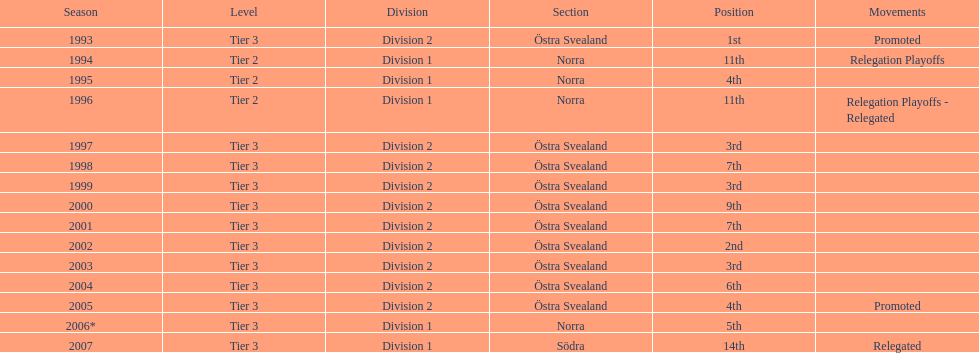Could you parse the entire table? {'header': ['Season', 'Level', 'Division', 'Section', 'Position', 'Movements'], 'rows': [['1993', 'Tier 3', 'Division 2', 'Östra Svealand', '1st', 'Promoted'], ['1994', 'Tier 2', 'Division 1', 'Norra', '11th', 'Relegation Playoffs'], ['1995', 'Tier 2', 'Division 1', 'Norra', '4th', ''], ['1996', 'Tier 2', 'Division 1', 'Norra', '11th', 'Relegation Playoffs - Relegated'], ['1997', 'Tier 3', 'Division 2', 'Östra Svealand', '3rd', ''], ['1998', 'Tier 3', 'Division 2', 'Östra Svealand', '7th', ''], ['1999', 'Tier 3', 'Division 2', 'Östra Svealand', '3rd', ''], ['2000', 'Tier 3', 'Division 2', 'Östra Svealand', '9th', ''], ['2001', 'Tier 3', 'Division 2', 'Östra Svealand', '7th', ''], ['2002', 'Tier 3', 'Division 2', 'Östra Svealand', '2nd', ''], ['2003', 'Tier 3', 'Division 2', 'Östra Svealand', '3rd', ''], ['2004', 'Tier 3', 'Division 2', 'Östra Svealand', '6th', ''], ['2005', 'Tier 3', 'Division 2', 'Östra Svealand', '4th', 'Promoted'], ['2006*', 'Tier 3', 'Division 1', 'Norra', '5th', ''], ['2007', 'Tier 3', 'Division 1', 'Södra', '14th', 'Relegated']]} What year was their top performance? 1993. 